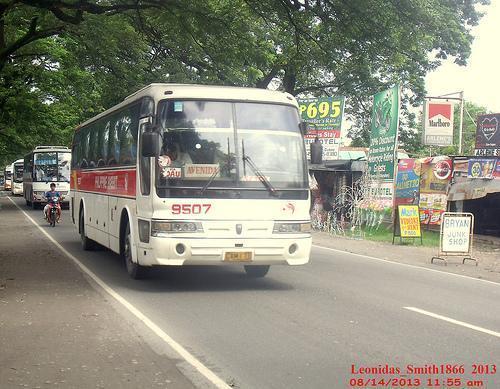How many red buses?
Give a very brief answer. 1. 